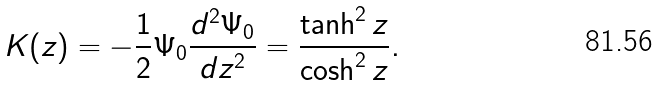Convert formula to latex. <formula><loc_0><loc_0><loc_500><loc_500>K ( z ) = - \frac { 1 } { 2 } \Psi _ { 0 } \frac { d ^ { 2 } \Psi _ { 0 } } { d z ^ { 2 } } = \frac { \tanh ^ { 2 } { z } } { \cosh ^ { 2 } { z } } .</formula> 